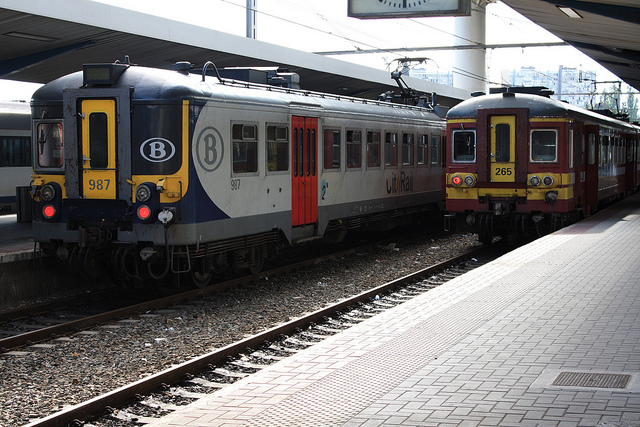What does the 'B' symbol on the train represent? The 'B' symbol on the train stands for the National Railway Company of Belgium (SNCB or NMBS), indicating these are Belgian trains. How can you tell the trains are not in motion? The platforms are clear and the trains appear to be aligned with the platform doors, suggesting they are stationary to allow passengers to board or alight. There is no motion blur that would indicate movement, reinforcing that they are at a standstill. 